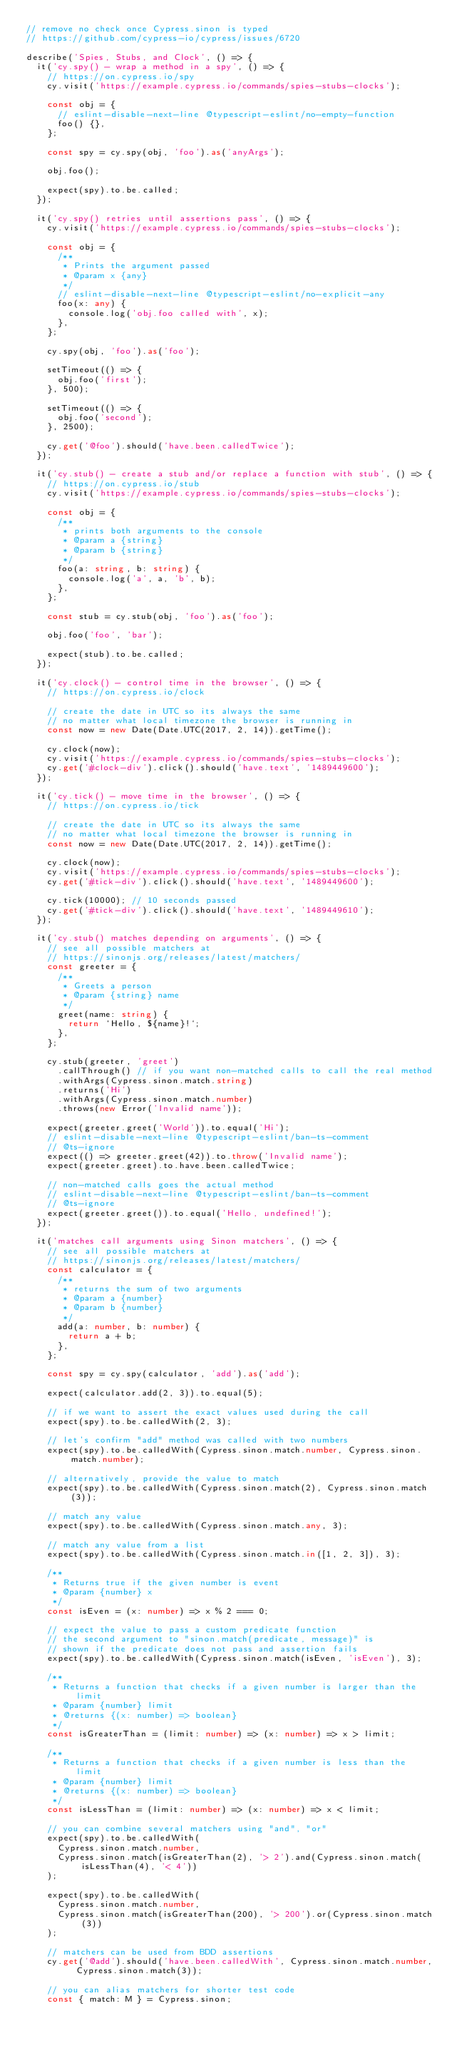<code> <loc_0><loc_0><loc_500><loc_500><_TypeScript_>// remove no check once Cypress.sinon is typed
// https://github.com/cypress-io/cypress/issues/6720

describe('Spies, Stubs, and Clock', () => {
  it('cy.spy() - wrap a method in a spy', () => {
    // https://on.cypress.io/spy
    cy.visit('https://example.cypress.io/commands/spies-stubs-clocks');

    const obj = {
      // eslint-disable-next-line @typescript-eslint/no-empty-function
      foo() {},
    };

    const spy = cy.spy(obj, 'foo').as('anyArgs');

    obj.foo();

    expect(spy).to.be.called;
  });

  it('cy.spy() retries until assertions pass', () => {
    cy.visit('https://example.cypress.io/commands/spies-stubs-clocks');

    const obj = {
      /**
       * Prints the argument passed
       * @param x {any}
       */
      // eslint-disable-next-line @typescript-eslint/no-explicit-any
      foo(x: any) {
        console.log('obj.foo called with', x);
      },
    };

    cy.spy(obj, 'foo').as('foo');

    setTimeout(() => {
      obj.foo('first');
    }, 500);

    setTimeout(() => {
      obj.foo('second');
    }, 2500);

    cy.get('@foo').should('have.been.calledTwice');
  });

  it('cy.stub() - create a stub and/or replace a function with stub', () => {
    // https://on.cypress.io/stub
    cy.visit('https://example.cypress.io/commands/spies-stubs-clocks');

    const obj = {
      /**
       * prints both arguments to the console
       * @param a {string}
       * @param b {string}
       */
      foo(a: string, b: string) {
        console.log('a', a, 'b', b);
      },
    };

    const stub = cy.stub(obj, 'foo').as('foo');

    obj.foo('foo', 'bar');

    expect(stub).to.be.called;
  });

  it('cy.clock() - control time in the browser', () => {
    // https://on.cypress.io/clock

    // create the date in UTC so its always the same
    // no matter what local timezone the browser is running in
    const now = new Date(Date.UTC(2017, 2, 14)).getTime();

    cy.clock(now);
    cy.visit('https://example.cypress.io/commands/spies-stubs-clocks');
    cy.get('#clock-div').click().should('have.text', '1489449600');
  });

  it('cy.tick() - move time in the browser', () => {
    // https://on.cypress.io/tick

    // create the date in UTC so its always the same
    // no matter what local timezone the browser is running in
    const now = new Date(Date.UTC(2017, 2, 14)).getTime();

    cy.clock(now);
    cy.visit('https://example.cypress.io/commands/spies-stubs-clocks');
    cy.get('#tick-div').click().should('have.text', '1489449600');

    cy.tick(10000); // 10 seconds passed
    cy.get('#tick-div').click().should('have.text', '1489449610');
  });

  it('cy.stub() matches depending on arguments', () => {
    // see all possible matchers at
    // https://sinonjs.org/releases/latest/matchers/
    const greeter = {
      /**
       * Greets a person
       * @param {string} name
       */
      greet(name: string) {
        return `Hello, ${name}!`;
      },
    };

    cy.stub(greeter, 'greet')
      .callThrough() // if you want non-matched calls to call the real method
      .withArgs(Cypress.sinon.match.string)
      .returns('Hi')
      .withArgs(Cypress.sinon.match.number)
      .throws(new Error('Invalid name'));

    expect(greeter.greet('World')).to.equal('Hi');
    // eslint-disable-next-line @typescript-eslint/ban-ts-comment
    // @ts-ignore
    expect(() => greeter.greet(42)).to.throw('Invalid name');
    expect(greeter.greet).to.have.been.calledTwice;

    // non-matched calls goes the actual method
    // eslint-disable-next-line @typescript-eslint/ban-ts-comment
    // @ts-ignore
    expect(greeter.greet()).to.equal('Hello, undefined!');
  });

  it('matches call arguments using Sinon matchers', () => {
    // see all possible matchers at
    // https://sinonjs.org/releases/latest/matchers/
    const calculator = {
      /**
       * returns the sum of two arguments
       * @param a {number}
       * @param b {number}
       */
      add(a: number, b: number) {
        return a + b;
      },
    };

    const spy = cy.spy(calculator, 'add').as('add');

    expect(calculator.add(2, 3)).to.equal(5);

    // if we want to assert the exact values used during the call
    expect(spy).to.be.calledWith(2, 3);

    // let's confirm "add" method was called with two numbers
    expect(spy).to.be.calledWith(Cypress.sinon.match.number, Cypress.sinon.match.number);

    // alternatively, provide the value to match
    expect(spy).to.be.calledWith(Cypress.sinon.match(2), Cypress.sinon.match(3));

    // match any value
    expect(spy).to.be.calledWith(Cypress.sinon.match.any, 3);

    // match any value from a list
    expect(spy).to.be.calledWith(Cypress.sinon.match.in([1, 2, 3]), 3);

    /**
     * Returns true if the given number is event
     * @param {number} x
     */
    const isEven = (x: number) => x % 2 === 0;

    // expect the value to pass a custom predicate function
    // the second argument to "sinon.match(predicate, message)" is
    // shown if the predicate does not pass and assertion fails
    expect(spy).to.be.calledWith(Cypress.sinon.match(isEven, 'isEven'), 3);

    /**
     * Returns a function that checks if a given number is larger than the limit
     * @param {number} limit
     * @returns {(x: number) => boolean}
     */
    const isGreaterThan = (limit: number) => (x: number) => x > limit;

    /**
     * Returns a function that checks if a given number is less than the limit
     * @param {number} limit
     * @returns {(x: number) => boolean}
     */
    const isLessThan = (limit: number) => (x: number) => x < limit;

    // you can combine several matchers using "and", "or"
    expect(spy).to.be.calledWith(
      Cypress.sinon.match.number,
      Cypress.sinon.match(isGreaterThan(2), '> 2').and(Cypress.sinon.match(isLessThan(4), '< 4'))
    );

    expect(spy).to.be.calledWith(
      Cypress.sinon.match.number,
      Cypress.sinon.match(isGreaterThan(200), '> 200').or(Cypress.sinon.match(3))
    );

    // matchers can be used from BDD assertions
    cy.get('@add').should('have.been.calledWith', Cypress.sinon.match.number, Cypress.sinon.match(3));

    // you can alias matchers for shorter test code
    const { match: M } = Cypress.sinon;
</code> 